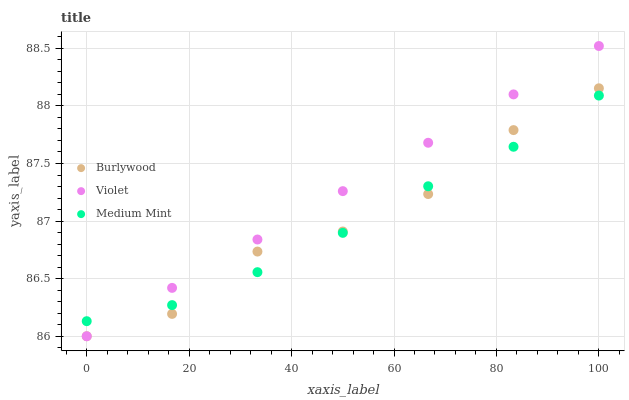Does Medium Mint have the minimum area under the curve?
Answer yes or no. Yes. Does Violet have the maximum area under the curve?
Answer yes or no. Yes. Does Violet have the minimum area under the curve?
Answer yes or no. No. Does Medium Mint have the maximum area under the curve?
Answer yes or no. No. Is Violet the smoothest?
Answer yes or no. Yes. Is Burlywood the roughest?
Answer yes or no. Yes. Is Medium Mint the smoothest?
Answer yes or no. No. Is Medium Mint the roughest?
Answer yes or no. No. Does Burlywood have the lowest value?
Answer yes or no. Yes. Does Medium Mint have the lowest value?
Answer yes or no. No. Does Violet have the highest value?
Answer yes or no. Yes. Does Medium Mint have the highest value?
Answer yes or no. No. Does Medium Mint intersect Burlywood?
Answer yes or no. Yes. Is Medium Mint less than Burlywood?
Answer yes or no. No. Is Medium Mint greater than Burlywood?
Answer yes or no. No. 